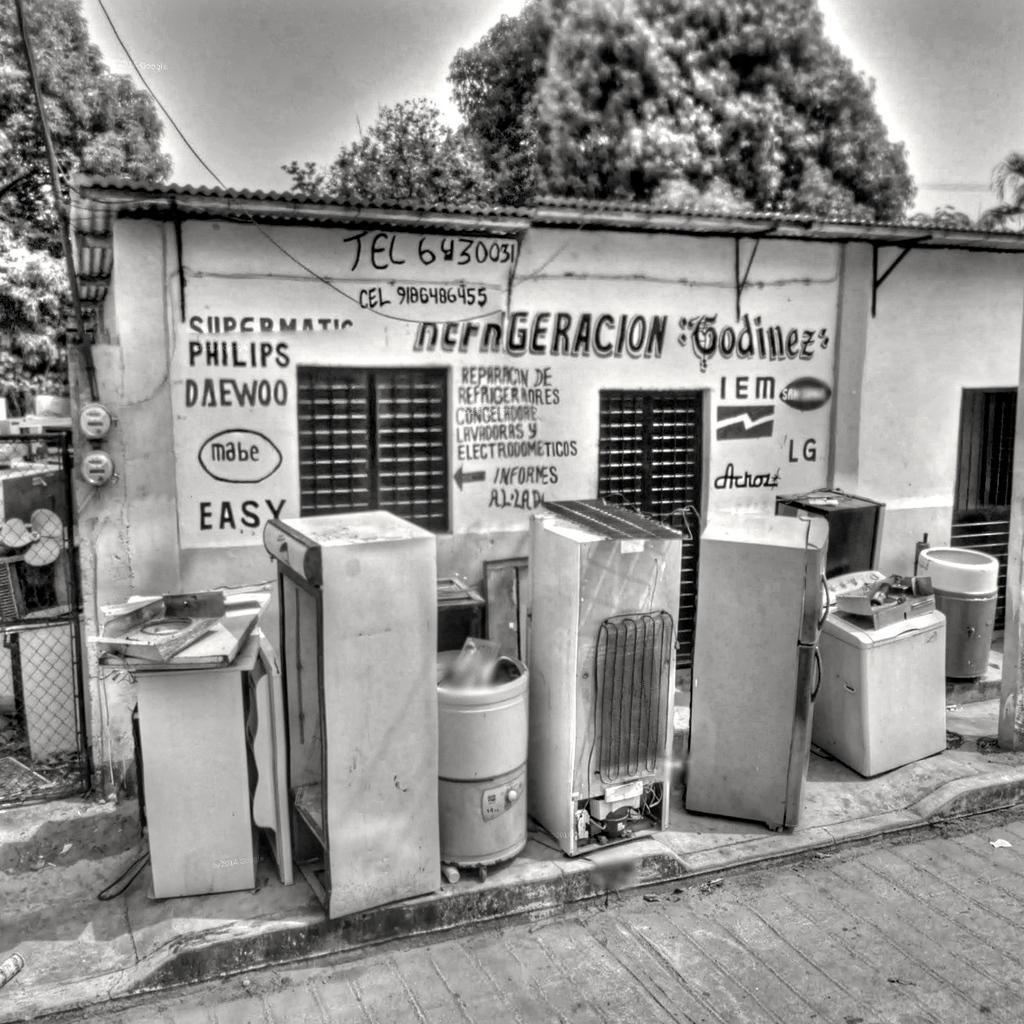Please provide a concise description of this image. This is a black and white image and here we can see a fridge, washing machine, rack and some containers. In the background, there is a shed and we can see some other objects and there are trees and ropes and we can see some text written on the wall. At the bottom, there is road and at the top, there is sky. 